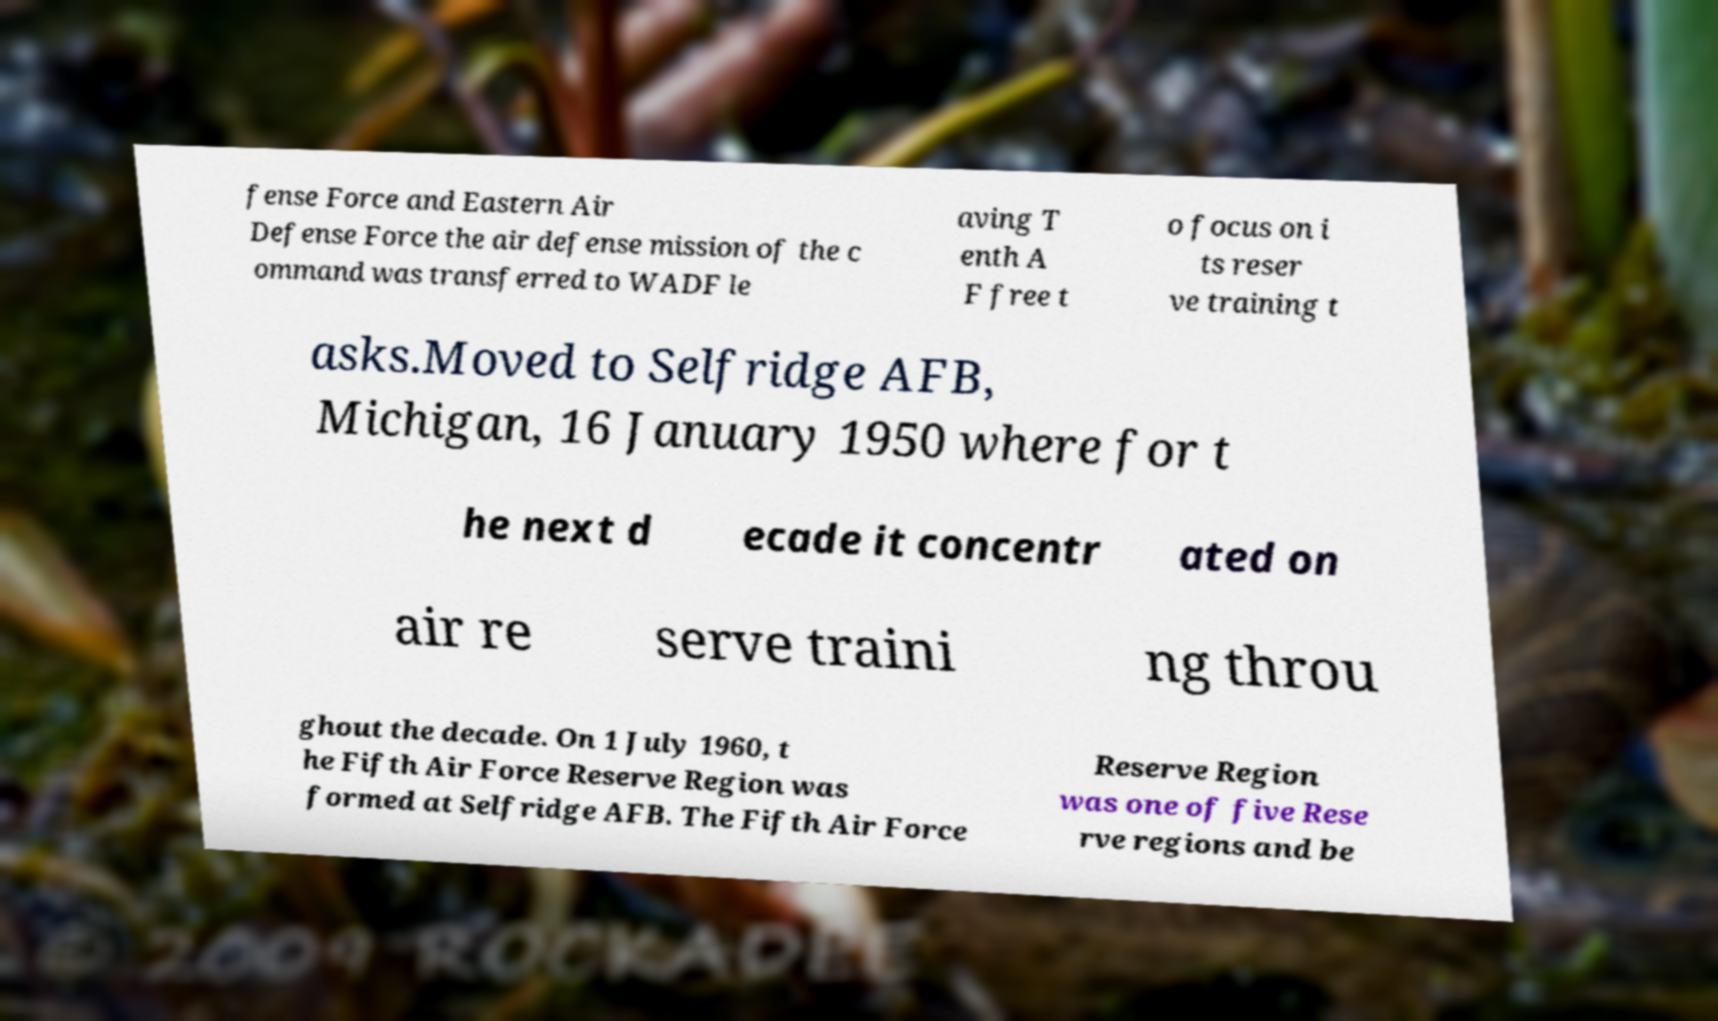Can you read and provide the text displayed in the image?This photo seems to have some interesting text. Can you extract and type it out for me? fense Force and Eastern Air Defense Force the air defense mission of the c ommand was transferred to WADF le aving T enth A F free t o focus on i ts reser ve training t asks.Moved to Selfridge AFB, Michigan, 16 January 1950 where for t he next d ecade it concentr ated on air re serve traini ng throu ghout the decade. On 1 July 1960, t he Fifth Air Force Reserve Region was formed at Selfridge AFB. The Fifth Air Force Reserve Region was one of five Rese rve regions and be 